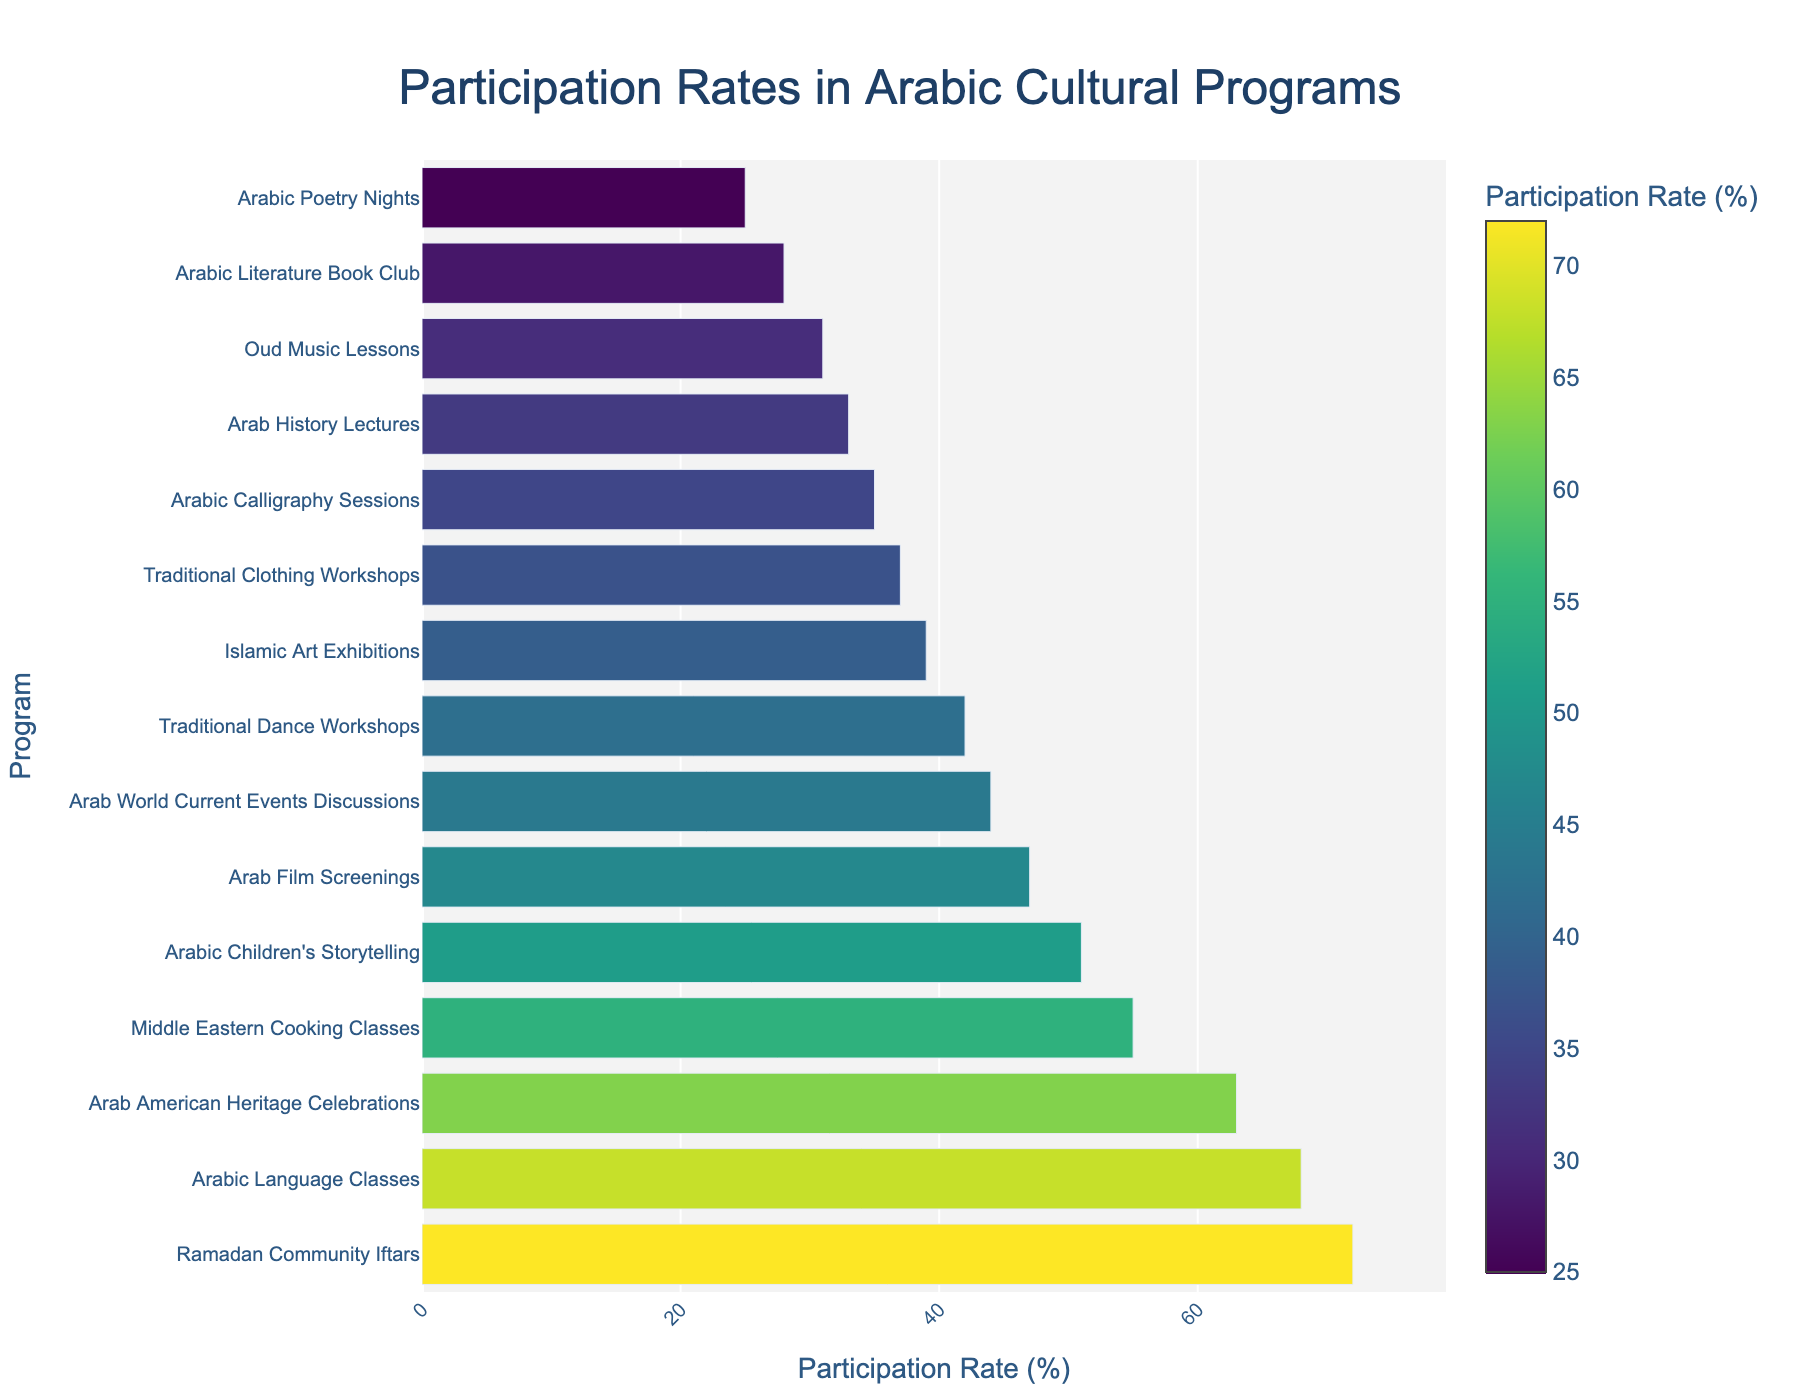Which program has the highest participation rate? The bar chart shows that the "Ramadan Community Iftars" program has the longest bar, indicating the highest participation rate.
Answer: Ramadan Community Iftars Which programs have a participation rate greater than 60%? By examining the bar chart, the programs with bars extending beyond the 60% mark are "Ramadan Community Iftars", "Arabic Language Classes", and "Arab American Heritage Celebrations".
Answer: Ramadan Community Iftars, Arabic Language Classes, Arab American Heritage Celebrations What is the participation rate of the Middle Eastern Cooking Classes? Locate the "Middle Eastern Cooking Classes" bar in the chart, then read the value next to it or along the horizontal axis. The bar reaches up to 55%.
Answer: 55% How much higher is the participation rate of "Ramadan Community Iftars" compared to "Arabic Poetry Nights"? "Ramadan Community Iftars" has a participation rate of 72%, and "Arabic Poetry Nights" has 25%. Calculate the difference: 72% - 25% = 47%.
Answer: 47% What's the average participation rate of all the programs? Sum up all the participation rates: 68 + 42 + 35 + 55 + 39 + 28 + 31 + 47 + 72 + 33 + 25 + 37 + 44 + 51 + 63 = 670. There are 15 programs, so the average is 670 / 15 ≈ 44.67%.
Answer: 44.67% Which program has a participation rate closest to the average participation rate? The average participation rate is approximately 44.67%. By comparing the rates, "Arab World Current Events Discussions" at 44% is the closest.
Answer: Arab World Current Events Discussions Are there more programs with a participation rate above 50% or below 50%? Count the bars above and below the 50% mark. There are 6 programs above 50% and 9 programs below.
Answer: Below 50% Why might the "Ramadan Community Iftars" have a higher participation rate than other programs? Consider factors such as cultural significance, the communal aspect of the event, and possible traditional importance, which could attract more participants.
Answer: Cultural significance and communal aspect Is the participation rate of "Arabic Literature Book Club" higher or lower than that of "Oud Music Lessons"? Compare the bars: "Arabic Literature Book Club" has 28%, and "Oud Music Lessons" has 31%. "Oud Music Lessons" has a higher rate.
Answer: Lower Which program has the second-lowest participation rate, and what is its value? Identify the second-shortest bar after "Arabic Poetry Nights", which is "Arabic Literature Book Club" with 28%.
Answer: Arabic Literature Book Club, 28% 